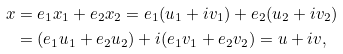<formula> <loc_0><loc_0><loc_500><loc_500>x & = e _ { 1 } x _ { 1 } + e _ { 2 } x _ { 2 } = e _ { 1 } ( u _ { 1 } + i v _ { 1 } ) + e _ { 2 } ( u _ { 2 } + i v _ { 2 } ) \\ & = ( e _ { 1 } u _ { 1 } + e _ { 2 } u _ { 2 } ) + i ( e _ { 1 } v _ { 1 } + e _ { 2 } v _ { 2 } ) = u + i v ,</formula> 